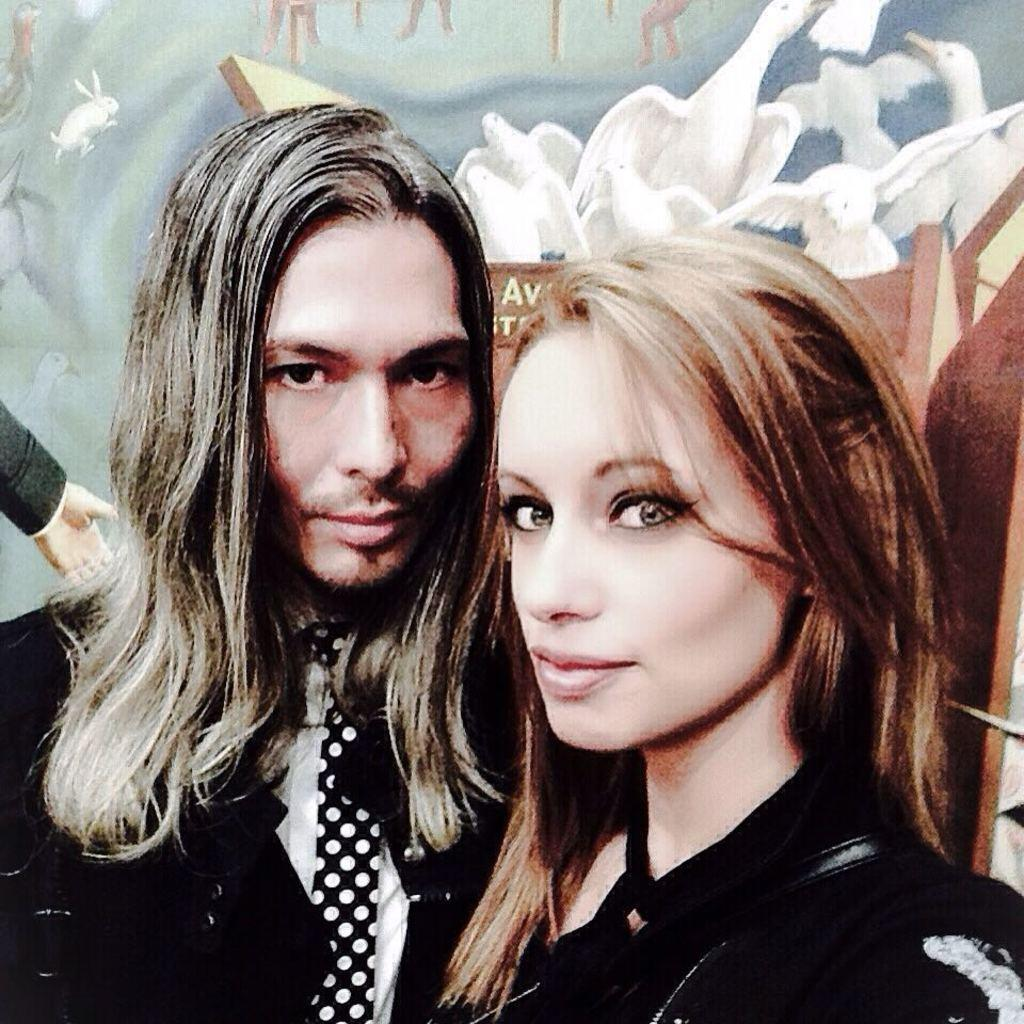How many people are present in the image? There are two people in the image, a man and a woman. What can be seen in the background of the image? There is a wall poster in the background of the image. What type of oil is being used by the man in the image? There is no oil present in the image, and the man is not using any oil. 